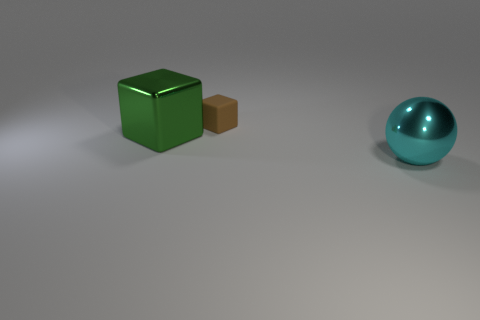Add 3 large blocks. How many objects exist? 6 Add 1 green blocks. How many green blocks are left? 2 Add 2 large yellow metallic cubes. How many large yellow metallic cubes exist? 2 Subtract 0 brown cylinders. How many objects are left? 3 Subtract all blocks. How many objects are left? 1 Subtract all blue blocks. Subtract all brown balls. How many blocks are left? 2 Subtract all purple metallic objects. Subtract all large cyan metallic objects. How many objects are left? 2 